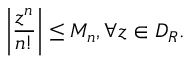Convert formula to latex. <formula><loc_0><loc_0><loc_500><loc_500>\left | { \frac { z ^ { n } } { n ! } } \right | \leq M _ { n } , \forall z \in D _ { R } .</formula> 